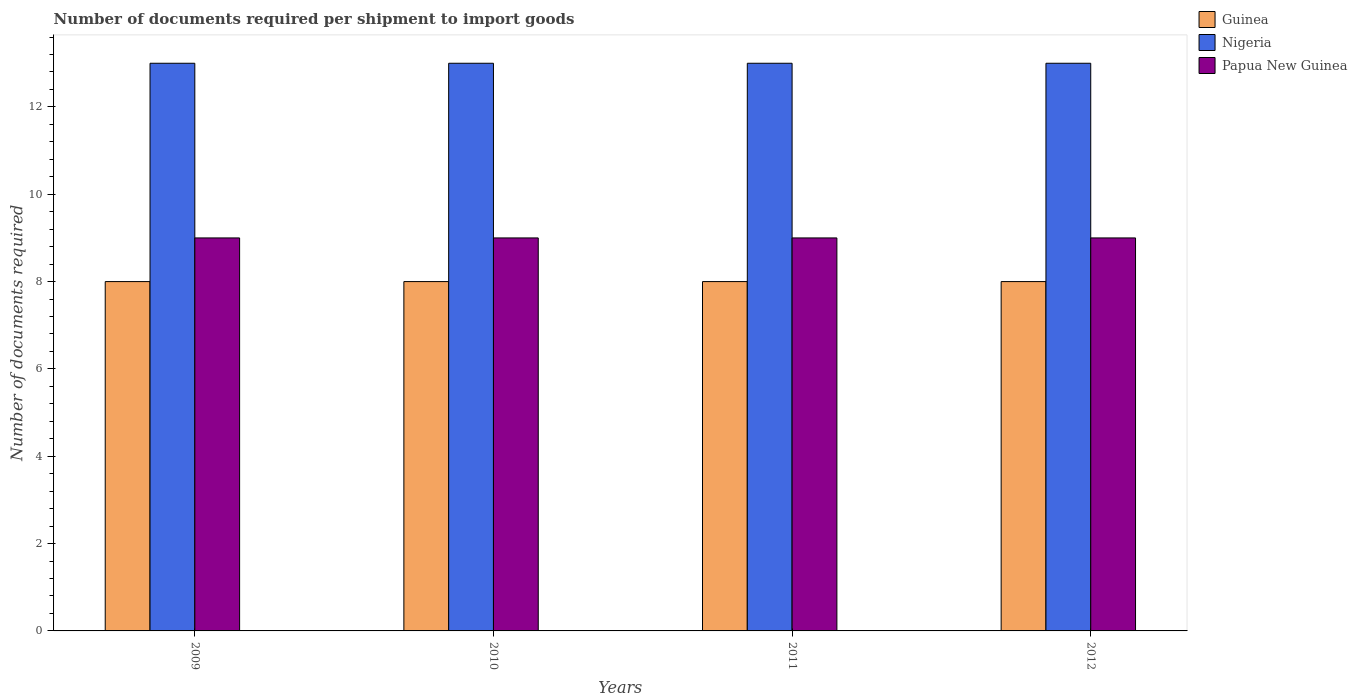Are the number of bars per tick equal to the number of legend labels?
Provide a short and direct response. Yes. Are the number of bars on each tick of the X-axis equal?
Offer a terse response. Yes. What is the label of the 1st group of bars from the left?
Provide a succinct answer. 2009. In how many cases, is the number of bars for a given year not equal to the number of legend labels?
Your response must be concise. 0. What is the number of documents required per shipment to import goods in Nigeria in 2009?
Give a very brief answer. 13. Across all years, what is the maximum number of documents required per shipment to import goods in Guinea?
Provide a short and direct response. 8. Across all years, what is the minimum number of documents required per shipment to import goods in Nigeria?
Your answer should be compact. 13. In which year was the number of documents required per shipment to import goods in Papua New Guinea maximum?
Keep it short and to the point. 2009. What is the total number of documents required per shipment to import goods in Nigeria in the graph?
Your answer should be compact. 52. What is the difference between the number of documents required per shipment to import goods in Nigeria in 2010 and that in 2012?
Your answer should be compact. 0. What is the difference between the number of documents required per shipment to import goods in Papua New Guinea in 2010 and the number of documents required per shipment to import goods in Guinea in 2009?
Give a very brief answer. 1. In the year 2012, what is the difference between the number of documents required per shipment to import goods in Papua New Guinea and number of documents required per shipment to import goods in Nigeria?
Offer a very short reply. -4. What is the ratio of the number of documents required per shipment to import goods in Papua New Guinea in 2009 to that in 2010?
Your response must be concise. 1. Is the number of documents required per shipment to import goods in Nigeria in 2011 less than that in 2012?
Give a very brief answer. No. What does the 2nd bar from the left in 2010 represents?
Your answer should be compact. Nigeria. What does the 3rd bar from the right in 2010 represents?
Ensure brevity in your answer.  Guinea. How many bars are there?
Give a very brief answer. 12. Does the graph contain any zero values?
Your answer should be very brief. No. How many legend labels are there?
Your response must be concise. 3. What is the title of the graph?
Keep it short and to the point. Number of documents required per shipment to import goods. What is the label or title of the Y-axis?
Offer a terse response. Number of documents required. What is the Number of documents required in Papua New Guinea in 2009?
Make the answer very short. 9. What is the Number of documents required of Guinea in 2012?
Your response must be concise. 8. Across all years, what is the maximum Number of documents required of Nigeria?
Make the answer very short. 13. Across all years, what is the minimum Number of documents required in Nigeria?
Your answer should be very brief. 13. What is the total Number of documents required of Guinea in the graph?
Offer a terse response. 32. What is the total Number of documents required of Papua New Guinea in the graph?
Make the answer very short. 36. What is the difference between the Number of documents required in Guinea in 2009 and that in 2010?
Offer a very short reply. 0. What is the difference between the Number of documents required of Nigeria in 2009 and that in 2010?
Give a very brief answer. 0. What is the difference between the Number of documents required of Nigeria in 2009 and that in 2012?
Provide a succinct answer. 0. What is the difference between the Number of documents required of Guinea in 2010 and that in 2012?
Make the answer very short. 0. What is the difference between the Number of documents required of Nigeria in 2010 and that in 2012?
Your answer should be compact. 0. What is the difference between the Number of documents required in Nigeria in 2011 and that in 2012?
Your answer should be compact. 0. What is the difference between the Number of documents required in Guinea in 2009 and the Number of documents required in Papua New Guinea in 2010?
Offer a very short reply. -1. What is the difference between the Number of documents required in Guinea in 2009 and the Number of documents required in Nigeria in 2011?
Provide a short and direct response. -5. What is the difference between the Number of documents required of Guinea in 2009 and the Number of documents required of Papua New Guinea in 2011?
Give a very brief answer. -1. What is the difference between the Number of documents required in Guinea in 2009 and the Number of documents required in Nigeria in 2012?
Offer a terse response. -5. What is the difference between the Number of documents required of Nigeria in 2010 and the Number of documents required of Papua New Guinea in 2012?
Your answer should be very brief. 4. What is the difference between the Number of documents required in Guinea in 2011 and the Number of documents required in Nigeria in 2012?
Your answer should be very brief. -5. What is the average Number of documents required of Papua New Guinea per year?
Offer a terse response. 9. In the year 2009, what is the difference between the Number of documents required of Nigeria and Number of documents required of Papua New Guinea?
Your response must be concise. 4. In the year 2011, what is the difference between the Number of documents required of Guinea and Number of documents required of Nigeria?
Your answer should be very brief. -5. In the year 2011, what is the difference between the Number of documents required in Guinea and Number of documents required in Papua New Guinea?
Your answer should be compact. -1. In the year 2012, what is the difference between the Number of documents required of Guinea and Number of documents required of Nigeria?
Offer a terse response. -5. In the year 2012, what is the difference between the Number of documents required of Nigeria and Number of documents required of Papua New Guinea?
Your answer should be very brief. 4. What is the ratio of the Number of documents required in Guinea in 2009 to that in 2010?
Keep it short and to the point. 1. What is the ratio of the Number of documents required in Guinea in 2009 to that in 2011?
Give a very brief answer. 1. What is the ratio of the Number of documents required in Nigeria in 2009 to that in 2011?
Provide a short and direct response. 1. What is the ratio of the Number of documents required in Guinea in 2009 to that in 2012?
Your answer should be very brief. 1. What is the ratio of the Number of documents required in Papua New Guinea in 2009 to that in 2012?
Your response must be concise. 1. What is the ratio of the Number of documents required in Papua New Guinea in 2010 to that in 2011?
Provide a succinct answer. 1. What is the ratio of the Number of documents required in Guinea in 2010 to that in 2012?
Your response must be concise. 1. What is the difference between the highest and the lowest Number of documents required in Nigeria?
Make the answer very short. 0. What is the difference between the highest and the lowest Number of documents required in Papua New Guinea?
Ensure brevity in your answer.  0. 